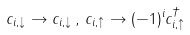Convert formula to latex. <formula><loc_0><loc_0><loc_500><loc_500>c _ { i , \downarrow } \rightarrow c _ { i , \downarrow } \, , \, c _ { i , \uparrow } \rightarrow ( - 1 ) ^ { i } c _ { i , \uparrow } ^ { \dagger }</formula> 